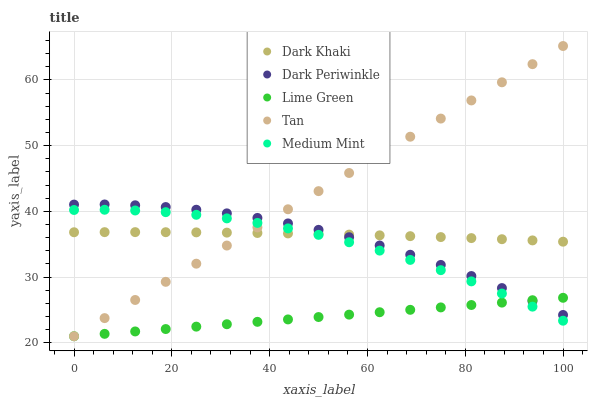Does Lime Green have the minimum area under the curve?
Answer yes or no. Yes. Does Tan have the maximum area under the curve?
Answer yes or no. Yes. Does Medium Mint have the minimum area under the curve?
Answer yes or no. No. Does Medium Mint have the maximum area under the curve?
Answer yes or no. No. Is Lime Green the smoothest?
Answer yes or no. Yes. Is Medium Mint the roughest?
Answer yes or no. Yes. Is Tan the smoothest?
Answer yes or no. No. Is Tan the roughest?
Answer yes or no. No. Does Tan have the lowest value?
Answer yes or no. Yes. Does Medium Mint have the lowest value?
Answer yes or no. No. Does Tan have the highest value?
Answer yes or no. Yes. Does Medium Mint have the highest value?
Answer yes or no. No. Is Medium Mint less than Dark Periwinkle?
Answer yes or no. Yes. Is Dark Periwinkle greater than Medium Mint?
Answer yes or no. Yes. Does Dark Khaki intersect Medium Mint?
Answer yes or no. Yes. Is Dark Khaki less than Medium Mint?
Answer yes or no. No. Is Dark Khaki greater than Medium Mint?
Answer yes or no. No. Does Medium Mint intersect Dark Periwinkle?
Answer yes or no. No. 